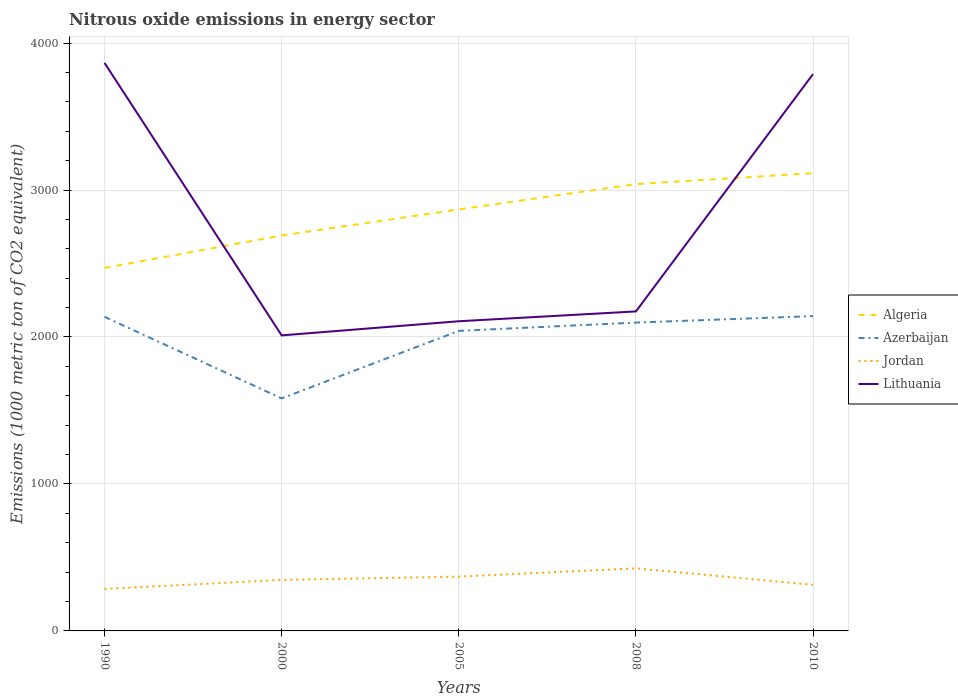Is the number of lines equal to the number of legend labels?
Offer a terse response. Yes. Across all years, what is the maximum amount of nitrous oxide emitted in Azerbaijan?
Keep it short and to the point. 1582.1. In which year was the amount of nitrous oxide emitted in Jordan maximum?
Your answer should be very brief. 1990. What is the total amount of nitrous oxide emitted in Lithuania in the graph?
Offer a terse response. -1778.3. What is the difference between the highest and the second highest amount of nitrous oxide emitted in Jordan?
Your response must be concise. 140.1. How many lines are there?
Offer a very short reply. 4. What is the difference between two consecutive major ticks on the Y-axis?
Your response must be concise. 1000. Does the graph contain any zero values?
Your answer should be compact. No. Does the graph contain grids?
Keep it short and to the point. Yes. How are the legend labels stacked?
Your answer should be compact. Vertical. What is the title of the graph?
Offer a terse response. Nitrous oxide emissions in energy sector. Does "Philippines" appear as one of the legend labels in the graph?
Offer a very short reply. No. What is the label or title of the X-axis?
Offer a terse response. Years. What is the label or title of the Y-axis?
Offer a very short reply. Emissions (1000 metric ton of CO2 equivalent). What is the Emissions (1000 metric ton of CO2 equivalent) in Algeria in 1990?
Make the answer very short. 2469.5. What is the Emissions (1000 metric ton of CO2 equivalent) of Azerbaijan in 1990?
Keep it short and to the point. 2137.1. What is the Emissions (1000 metric ton of CO2 equivalent) of Jordan in 1990?
Your response must be concise. 285.6. What is the Emissions (1000 metric ton of CO2 equivalent) of Lithuania in 1990?
Provide a short and direct response. 3865. What is the Emissions (1000 metric ton of CO2 equivalent) of Algeria in 2000?
Your response must be concise. 2690.4. What is the Emissions (1000 metric ton of CO2 equivalent) of Azerbaijan in 2000?
Offer a very short reply. 1582.1. What is the Emissions (1000 metric ton of CO2 equivalent) in Jordan in 2000?
Offer a very short reply. 347.2. What is the Emissions (1000 metric ton of CO2 equivalent) of Lithuania in 2000?
Your response must be concise. 2010.8. What is the Emissions (1000 metric ton of CO2 equivalent) of Algeria in 2005?
Your response must be concise. 2868.2. What is the Emissions (1000 metric ton of CO2 equivalent) in Azerbaijan in 2005?
Provide a succinct answer. 2041.5. What is the Emissions (1000 metric ton of CO2 equivalent) of Jordan in 2005?
Your response must be concise. 369.5. What is the Emissions (1000 metric ton of CO2 equivalent) of Lithuania in 2005?
Offer a very short reply. 2107. What is the Emissions (1000 metric ton of CO2 equivalent) in Algeria in 2008?
Ensure brevity in your answer.  3040.1. What is the Emissions (1000 metric ton of CO2 equivalent) in Azerbaijan in 2008?
Your response must be concise. 2098. What is the Emissions (1000 metric ton of CO2 equivalent) in Jordan in 2008?
Keep it short and to the point. 425.7. What is the Emissions (1000 metric ton of CO2 equivalent) in Lithuania in 2008?
Make the answer very short. 2173.9. What is the Emissions (1000 metric ton of CO2 equivalent) in Algeria in 2010?
Give a very brief answer. 3114.6. What is the Emissions (1000 metric ton of CO2 equivalent) of Azerbaijan in 2010?
Provide a short and direct response. 2142.1. What is the Emissions (1000 metric ton of CO2 equivalent) of Jordan in 2010?
Provide a succinct answer. 313.4. What is the Emissions (1000 metric ton of CO2 equivalent) in Lithuania in 2010?
Your answer should be very brief. 3789.1. Across all years, what is the maximum Emissions (1000 metric ton of CO2 equivalent) of Algeria?
Make the answer very short. 3114.6. Across all years, what is the maximum Emissions (1000 metric ton of CO2 equivalent) in Azerbaijan?
Your response must be concise. 2142.1. Across all years, what is the maximum Emissions (1000 metric ton of CO2 equivalent) in Jordan?
Give a very brief answer. 425.7. Across all years, what is the maximum Emissions (1000 metric ton of CO2 equivalent) in Lithuania?
Your response must be concise. 3865. Across all years, what is the minimum Emissions (1000 metric ton of CO2 equivalent) in Algeria?
Offer a very short reply. 2469.5. Across all years, what is the minimum Emissions (1000 metric ton of CO2 equivalent) of Azerbaijan?
Provide a succinct answer. 1582.1. Across all years, what is the minimum Emissions (1000 metric ton of CO2 equivalent) of Jordan?
Your response must be concise. 285.6. Across all years, what is the minimum Emissions (1000 metric ton of CO2 equivalent) in Lithuania?
Your answer should be compact. 2010.8. What is the total Emissions (1000 metric ton of CO2 equivalent) in Algeria in the graph?
Your answer should be compact. 1.42e+04. What is the total Emissions (1000 metric ton of CO2 equivalent) of Azerbaijan in the graph?
Ensure brevity in your answer.  1.00e+04. What is the total Emissions (1000 metric ton of CO2 equivalent) in Jordan in the graph?
Provide a succinct answer. 1741.4. What is the total Emissions (1000 metric ton of CO2 equivalent) of Lithuania in the graph?
Your answer should be very brief. 1.39e+04. What is the difference between the Emissions (1000 metric ton of CO2 equivalent) of Algeria in 1990 and that in 2000?
Your response must be concise. -220.9. What is the difference between the Emissions (1000 metric ton of CO2 equivalent) of Azerbaijan in 1990 and that in 2000?
Your answer should be compact. 555. What is the difference between the Emissions (1000 metric ton of CO2 equivalent) in Jordan in 1990 and that in 2000?
Your response must be concise. -61.6. What is the difference between the Emissions (1000 metric ton of CO2 equivalent) in Lithuania in 1990 and that in 2000?
Provide a short and direct response. 1854.2. What is the difference between the Emissions (1000 metric ton of CO2 equivalent) in Algeria in 1990 and that in 2005?
Make the answer very short. -398.7. What is the difference between the Emissions (1000 metric ton of CO2 equivalent) in Azerbaijan in 1990 and that in 2005?
Provide a short and direct response. 95.6. What is the difference between the Emissions (1000 metric ton of CO2 equivalent) of Jordan in 1990 and that in 2005?
Give a very brief answer. -83.9. What is the difference between the Emissions (1000 metric ton of CO2 equivalent) in Lithuania in 1990 and that in 2005?
Offer a very short reply. 1758. What is the difference between the Emissions (1000 metric ton of CO2 equivalent) of Algeria in 1990 and that in 2008?
Give a very brief answer. -570.6. What is the difference between the Emissions (1000 metric ton of CO2 equivalent) in Azerbaijan in 1990 and that in 2008?
Provide a succinct answer. 39.1. What is the difference between the Emissions (1000 metric ton of CO2 equivalent) of Jordan in 1990 and that in 2008?
Your answer should be compact. -140.1. What is the difference between the Emissions (1000 metric ton of CO2 equivalent) of Lithuania in 1990 and that in 2008?
Offer a terse response. 1691.1. What is the difference between the Emissions (1000 metric ton of CO2 equivalent) in Algeria in 1990 and that in 2010?
Your answer should be compact. -645.1. What is the difference between the Emissions (1000 metric ton of CO2 equivalent) of Jordan in 1990 and that in 2010?
Provide a succinct answer. -27.8. What is the difference between the Emissions (1000 metric ton of CO2 equivalent) of Lithuania in 1990 and that in 2010?
Your answer should be very brief. 75.9. What is the difference between the Emissions (1000 metric ton of CO2 equivalent) of Algeria in 2000 and that in 2005?
Offer a very short reply. -177.8. What is the difference between the Emissions (1000 metric ton of CO2 equivalent) in Azerbaijan in 2000 and that in 2005?
Provide a succinct answer. -459.4. What is the difference between the Emissions (1000 metric ton of CO2 equivalent) of Jordan in 2000 and that in 2005?
Offer a terse response. -22.3. What is the difference between the Emissions (1000 metric ton of CO2 equivalent) in Lithuania in 2000 and that in 2005?
Make the answer very short. -96.2. What is the difference between the Emissions (1000 metric ton of CO2 equivalent) of Algeria in 2000 and that in 2008?
Your answer should be very brief. -349.7. What is the difference between the Emissions (1000 metric ton of CO2 equivalent) in Azerbaijan in 2000 and that in 2008?
Give a very brief answer. -515.9. What is the difference between the Emissions (1000 metric ton of CO2 equivalent) of Jordan in 2000 and that in 2008?
Offer a terse response. -78.5. What is the difference between the Emissions (1000 metric ton of CO2 equivalent) in Lithuania in 2000 and that in 2008?
Offer a very short reply. -163.1. What is the difference between the Emissions (1000 metric ton of CO2 equivalent) of Algeria in 2000 and that in 2010?
Provide a short and direct response. -424.2. What is the difference between the Emissions (1000 metric ton of CO2 equivalent) of Azerbaijan in 2000 and that in 2010?
Provide a short and direct response. -560. What is the difference between the Emissions (1000 metric ton of CO2 equivalent) in Jordan in 2000 and that in 2010?
Offer a terse response. 33.8. What is the difference between the Emissions (1000 metric ton of CO2 equivalent) in Lithuania in 2000 and that in 2010?
Your answer should be compact. -1778.3. What is the difference between the Emissions (1000 metric ton of CO2 equivalent) of Algeria in 2005 and that in 2008?
Give a very brief answer. -171.9. What is the difference between the Emissions (1000 metric ton of CO2 equivalent) of Azerbaijan in 2005 and that in 2008?
Provide a succinct answer. -56.5. What is the difference between the Emissions (1000 metric ton of CO2 equivalent) of Jordan in 2005 and that in 2008?
Offer a very short reply. -56.2. What is the difference between the Emissions (1000 metric ton of CO2 equivalent) of Lithuania in 2005 and that in 2008?
Offer a very short reply. -66.9. What is the difference between the Emissions (1000 metric ton of CO2 equivalent) of Algeria in 2005 and that in 2010?
Your answer should be compact. -246.4. What is the difference between the Emissions (1000 metric ton of CO2 equivalent) in Azerbaijan in 2005 and that in 2010?
Provide a succinct answer. -100.6. What is the difference between the Emissions (1000 metric ton of CO2 equivalent) in Jordan in 2005 and that in 2010?
Your answer should be very brief. 56.1. What is the difference between the Emissions (1000 metric ton of CO2 equivalent) in Lithuania in 2005 and that in 2010?
Provide a succinct answer. -1682.1. What is the difference between the Emissions (1000 metric ton of CO2 equivalent) in Algeria in 2008 and that in 2010?
Give a very brief answer. -74.5. What is the difference between the Emissions (1000 metric ton of CO2 equivalent) in Azerbaijan in 2008 and that in 2010?
Give a very brief answer. -44.1. What is the difference between the Emissions (1000 metric ton of CO2 equivalent) in Jordan in 2008 and that in 2010?
Provide a succinct answer. 112.3. What is the difference between the Emissions (1000 metric ton of CO2 equivalent) in Lithuania in 2008 and that in 2010?
Your response must be concise. -1615.2. What is the difference between the Emissions (1000 metric ton of CO2 equivalent) of Algeria in 1990 and the Emissions (1000 metric ton of CO2 equivalent) of Azerbaijan in 2000?
Keep it short and to the point. 887.4. What is the difference between the Emissions (1000 metric ton of CO2 equivalent) in Algeria in 1990 and the Emissions (1000 metric ton of CO2 equivalent) in Jordan in 2000?
Ensure brevity in your answer.  2122.3. What is the difference between the Emissions (1000 metric ton of CO2 equivalent) of Algeria in 1990 and the Emissions (1000 metric ton of CO2 equivalent) of Lithuania in 2000?
Your answer should be compact. 458.7. What is the difference between the Emissions (1000 metric ton of CO2 equivalent) of Azerbaijan in 1990 and the Emissions (1000 metric ton of CO2 equivalent) of Jordan in 2000?
Offer a very short reply. 1789.9. What is the difference between the Emissions (1000 metric ton of CO2 equivalent) in Azerbaijan in 1990 and the Emissions (1000 metric ton of CO2 equivalent) in Lithuania in 2000?
Your response must be concise. 126.3. What is the difference between the Emissions (1000 metric ton of CO2 equivalent) in Jordan in 1990 and the Emissions (1000 metric ton of CO2 equivalent) in Lithuania in 2000?
Keep it short and to the point. -1725.2. What is the difference between the Emissions (1000 metric ton of CO2 equivalent) of Algeria in 1990 and the Emissions (1000 metric ton of CO2 equivalent) of Azerbaijan in 2005?
Provide a short and direct response. 428. What is the difference between the Emissions (1000 metric ton of CO2 equivalent) in Algeria in 1990 and the Emissions (1000 metric ton of CO2 equivalent) in Jordan in 2005?
Ensure brevity in your answer.  2100. What is the difference between the Emissions (1000 metric ton of CO2 equivalent) of Algeria in 1990 and the Emissions (1000 metric ton of CO2 equivalent) of Lithuania in 2005?
Give a very brief answer. 362.5. What is the difference between the Emissions (1000 metric ton of CO2 equivalent) of Azerbaijan in 1990 and the Emissions (1000 metric ton of CO2 equivalent) of Jordan in 2005?
Your answer should be compact. 1767.6. What is the difference between the Emissions (1000 metric ton of CO2 equivalent) in Azerbaijan in 1990 and the Emissions (1000 metric ton of CO2 equivalent) in Lithuania in 2005?
Provide a short and direct response. 30.1. What is the difference between the Emissions (1000 metric ton of CO2 equivalent) in Jordan in 1990 and the Emissions (1000 metric ton of CO2 equivalent) in Lithuania in 2005?
Keep it short and to the point. -1821.4. What is the difference between the Emissions (1000 metric ton of CO2 equivalent) of Algeria in 1990 and the Emissions (1000 metric ton of CO2 equivalent) of Azerbaijan in 2008?
Provide a succinct answer. 371.5. What is the difference between the Emissions (1000 metric ton of CO2 equivalent) in Algeria in 1990 and the Emissions (1000 metric ton of CO2 equivalent) in Jordan in 2008?
Ensure brevity in your answer.  2043.8. What is the difference between the Emissions (1000 metric ton of CO2 equivalent) in Algeria in 1990 and the Emissions (1000 metric ton of CO2 equivalent) in Lithuania in 2008?
Provide a succinct answer. 295.6. What is the difference between the Emissions (1000 metric ton of CO2 equivalent) of Azerbaijan in 1990 and the Emissions (1000 metric ton of CO2 equivalent) of Jordan in 2008?
Keep it short and to the point. 1711.4. What is the difference between the Emissions (1000 metric ton of CO2 equivalent) in Azerbaijan in 1990 and the Emissions (1000 metric ton of CO2 equivalent) in Lithuania in 2008?
Make the answer very short. -36.8. What is the difference between the Emissions (1000 metric ton of CO2 equivalent) of Jordan in 1990 and the Emissions (1000 metric ton of CO2 equivalent) of Lithuania in 2008?
Your response must be concise. -1888.3. What is the difference between the Emissions (1000 metric ton of CO2 equivalent) of Algeria in 1990 and the Emissions (1000 metric ton of CO2 equivalent) of Azerbaijan in 2010?
Provide a succinct answer. 327.4. What is the difference between the Emissions (1000 metric ton of CO2 equivalent) of Algeria in 1990 and the Emissions (1000 metric ton of CO2 equivalent) of Jordan in 2010?
Your answer should be very brief. 2156.1. What is the difference between the Emissions (1000 metric ton of CO2 equivalent) in Algeria in 1990 and the Emissions (1000 metric ton of CO2 equivalent) in Lithuania in 2010?
Ensure brevity in your answer.  -1319.6. What is the difference between the Emissions (1000 metric ton of CO2 equivalent) of Azerbaijan in 1990 and the Emissions (1000 metric ton of CO2 equivalent) of Jordan in 2010?
Provide a succinct answer. 1823.7. What is the difference between the Emissions (1000 metric ton of CO2 equivalent) of Azerbaijan in 1990 and the Emissions (1000 metric ton of CO2 equivalent) of Lithuania in 2010?
Make the answer very short. -1652. What is the difference between the Emissions (1000 metric ton of CO2 equivalent) in Jordan in 1990 and the Emissions (1000 metric ton of CO2 equivalent) in Lithuania in 2010?
Ensure brevity in your answer.  -3503.5. What is the difference between the Emissions (1000 metric ton of CO2 equivalent) of Algeria in 2000 and the Emissions (1000 metric ton of CO2 equivalent) of Azerbaijan in 2005?
Your answer should be very brief. 648.9. What is the difference between the Emissions (1000 metric ton of CO2 equivalent) in Algeria in 2000 and the Emissions (1000 metric ton of CO2 equivalent) in Jordan in 2005?
Make the answer very short. 2320.9. What is the difference between the Emissions (1000 metric ton of CO2 equivalent) in Algeria in 2000 and the Emissions (1000 metric ton of CO2 equivalent) in Lithuania in 2005?
Provide a short and direct response. 583.4. What is the difference between the Emissions (1000 metric ton of CO2 equivalent) of Azerbaijan in 2000 and the Emissions (1000 metric ton of CO2 equivalent) of Jordan in 2005?
Offer a very short reply. 1212.6. What is the difference between the Emissions (1000 metric ton of CO2 equivalent) in Azerbaijan in 2000 and the Emissions (1000 metric ton of CO2 equivalent) in Lithuania in 2005?
Your answer should be compact. -524.9. What is the difference between the Emissions (1000 metric ton of CO2 equivalent) in Jordan in 2000 and the Emissions (1000 metric ton of CO2 equivalent) in Lithuania in 2005?
Give a very brief answer. -1759.8. What is the difference between the Emissions (1000 metric ton of CO2 equivalent) in Algeria in 2000 and the Emissions (1000 metric ton of CO2 equivalent) in Azerbaijan in 2008?
Ensure brevity in your answer.  592.4. What is the difference between the Emissions (1000 metric ton of CO2 equivalent) of Algeria in 2000 and the Emissions (1000 metric ton of CO2 equivalent) of Jordan in 2008?
Your answer should be compact. 2264.7. What is the difference between the Emissions (1000 metric ton of CO2 equivalent) in Algeria in 2000 and the Emissions (1000 metric ton of CO2 equivalent) in Lithuania in 2008?
Your answer should be very brief. 516.5. What is the difference between the Emissions (1000 metric ton of CO2 equivalent) in Azerbaijan in 2000 and the Emissions (1000 metric ton of CO2 equivalent) in Jordan in 2008?
Your answer should be compact. 1156.4. What is the difference between the Emissions (1000 metric ton of CO2 equivalent) of Azerbaijan in 2000 and the Emissions (1000 metric ton of CO2 equivalent) of Lithuania in 2008?
Offer a very short reply. -591.8. What is the difference between the Emissions (1000 metric ton of CO2 equivalent) in Jordan in 2000 and the Emissions (1000 metric ton of CO2 equivalent) in Lithuania in 2008?
Ensure brevity in your answer.  -1826.7. What is the difference between the Emissions (1000 metric ton of CO2 equivalent) in Algeria in 2000 and the Emissions (1000 metric ton of CO2 equivalent) in Azerbaijan in 2010?
Your answer should be compact. 548.3. What is the difference between the Emissions (1000 metric ton of CO2 equivalent) of Algeria in 2000 and the Emissions (1000 metric ton of CO2 equivalent) of Jordan in 2010?
Provide a short and direct response. 2377. What is the difference between the Emissions (1000 metric ton of CO2 equivalent) in Algeria in 2000 and the Emissions (1000 metric ton of CO2 equivalent) in Lithuania in 2010?
Your answer should be very brief. -1098.7. What is the difference between the Emissions (1000 metric ton of CO2 equivalent) of Azerbaijan in 2000 and the Emissions (1000 metric ton of CO2 equivalent) of Jordan in 2010?
Your answer should be compact. 1268.7. What is the difference between the Emissions (1000 metric ton of CO2 equivalent) in Azerbaijan in 2000 and the Emissions (1000 metric ton of CO2 equivalent) in Lithuania in 2010?
Ensure brevity in your answer.  -2207. What is the difference between the Emissions (1000 metric ton of CO2 equivalent) in Jordan in 2000 and the Emissions (1000 metric ton of CO2 equivalent) in Lithuania in 2010?
Your answer should be compact. -3441.9. What is the difference between the Emissions (1000 metric ton of CO2 equivalent) of Algeria in 2005 and the Emissions (1000 metric ton of CO2 equivalent) of Azerbaijan in 2008?
Offer a terse response. 770.2. What is the difference between the Emissions (1000 metric ton of CO2 equivalent) in Algeria in 2005 and the Emissions (1000 metric ton of CO2 equivalent) in Jordan in 2008?
Provide a succinct answer. 2442.5. What is the difference between the Emissions (1000 metric ton of CO2 equivalent) of Algeria in 2005 and the Emissions (1000 metric ton of CO2 equivalent) of Lithuania in 2008?
Your answer should be very brief. 694.3. What is the difference between the Emissions (1000 metric ton of CO2 equivalent) of Azerbaijan in 2005 and the Emissions (1000 metric ton of CO2 equivalent) of Jordan in 2008?
Give a very brief answer. 1615.8. What is the difference between the Emissions (1000 metric ton of CO2 equivalent) in Azerbaijan in 2005 and the Emissions (1000 metric ton of CO2 equivalent) in Lithuania in 2008?
Offer a very short reply. -132.4. What is the difference between the Emissions (1000 metric ton of CO2 equivalent) of Jordan in 2005 and the Emissions (1000 metric ton of CO2 equivalent) of Lithuania in 2008?
Keep it short and to the point. -1804.4. What is the difference between the Emissions (1000 metric ton of CO2 equivalent) of Algeria in 2005 and the Emissions (1000 metric ton of CO2 equivalent) of Azerbaijan in 2010?
Your response must be concise. 726.1. What is the difference between the Emissions (1000 metric ton of CO2 equivalent) in Algeria in 2005 and the Emissions (1000 metric ton of CO2 equivalent) in Jordan in 2010?
Give a very brief answer. 2554.8. What is the difference between the Emissions (1000 metric ton of CO2 equivalent) in Algeria in 2005 and the Emissions (1000 metric ton of CO2 equivalent) in Lithuania in 2010?
Keep it short and to the point. -920.9. What is the difference between the Emissions (1000 metric ton of CO2 equivalent) in Azerbaijan in 2005 and the Emissions (1000 metric ton of CO2 equivalent) in Jordan in 2010?
Your answer should be very brief. 1728.1. What is the difference between the Emissions (1000 metric ton of CO2 equivalent) in Azerbaijan in 2005 and the Emissions (1000 metric ton of CO2 equivalent) in Lithuania in 2010?
Your answer should be very brief. -1747.6. What is the difference between the Emissions (1000 metric ton of CO2 equivalent) of Jordan in 2005 and the Emissions (1000 metric ton of CO2 equivalent) of Lithuania in 2010?
Provide a short and direct response. -3419.6. What is the difference between the Emissions (1000 metric ton of CO2 equivalent) in Algeria in 2008 and the Emissions (1000 metric ton of CO2 equivalent) in Azerbaijan in 2010?
Provide a short and direct response. 898. What is the difference between the Emissions (1000 metric ton of CO2 equivalent) of Algeria in 2008 and the Emissions (1000 metric ton of CO2 equivalent) of Jordan in 2010?
Keep it short and to the point. 2726.7. What is the difference between the Emissions (1000 metric ton of CO2 equivalent) in Algeria in 2008 and the Emissions (1000 metric ton of CO2 equivalent) in Lithuania in 2010?
Your answer should be compact. -749. What is the difference between the Emissions (1000 metric ton of CO2 equivalent) of Azerbaijan in 2008 and the Emissions (1000 metric ton of CO2 equivalent) of Jordan in 2010?
Make the answer very short. 1784.6. What is the difference between the Emissions (1000 metric ton of CO2 equivalent) of Azerbaijan in 2008 and the Emissions (1000 metric ton of CO2 equivalent) of Lithuania in 2010?
Your answer should be very brief. -1691.1. What is the difference between the Emissions (1000 metric ton of CO2 equivalent) of Jordan in 2008 and the Emissions (1000 metric ton of CO2 equivalent) of Lithuania in 2010?
Your answer should be compact. -3363.4. What is the average Emissions (1000 metric ton of CO2 equivalent) in Algeria per year?
Your answer should be very brief. 2836.56. What is the average Emissions (1000 metric ton of CO2 equivalent) in Azerbaijan per year?
Give a very brief answer. 2000.16. What is the average Emissions (1000 metric ton of CO2 equivalent) in Jordan per year?
Give a very brief answer. 348.28. What is the average Emissions (1000 metric ton of CO2 equivalent) in Lithuania per year?
Provide a succinct answer. 2789.16. In the year 1990, what is the difference between the Emissions (1000 metric ton of CO2 equivalent) of Algeria and Emissions (1000 metric ton of CO2 equivalent) of Azerbaijan?
Ensure brevity in your answer.  332.4. In the year 1990, what is the difference between the Emissions (1000 metric ton of CO2 equivalent) of Algeria and Emissions (1000 metric ton of CO2 equivalent) of Jordan?
Make the answer very short. 2183.9. In the year 1990, what is the difference between the Emissions (1000 metric ton of CO2 equivalent) of Algeria and Emissions (1000 metric ton of CO2 equivalent) of Lithuania?
Provide a short and direct response. -1395.5. In the year 1990, what is the difference between the Emissions (1000 metric ton of CO2 equivalent) in Azerbaijan and Emissions (1000 metric ton of CO2 equivalent) in Jordan?
Offer a terse response. 1851.5. In the year 1990, what is the difference between the Emissions (1000 metric ton of CO2 equivalent) in Azerbaijan and Emissions (1000 metric ton of CO2 equivalent) in Lithuania?
Provide a succinct answer. -1727.9. In the year 1990, what is the difference between the Emissions (1000 metric ton of CO2 equivalent) in Jordan and Emissions (1000 metric ton of CO2 equivalent) in Lithuania?
Provide a short and direct response. -3579.4. In the year 2000, what is the difference between the Emissions (1000 metric ton of CO2 equivalent) in Algeria and Emissions (1000 metric ton of CO2 equivalent) in Azerbaijan?
Give a very brief answer. 1108.3. In the year 2000, what is the difference between the Emissions (1000 metric ton of CO2 equivalent) of Algeria and Emissions (1000 metric ton of CO2 equivalent) of Jordan?
Your answer should be very brief. 2343.2. In the year 2000, what is the difference between the Emissions (1000 metric ton of CO2 equivalent) of Algeria and Emissions (1000 metric ton of CO2 equivalent) of Lithuania?
Provide a succinct answer. 679.6. In the year 2000, what is the difference between the Emissions (1000 metric ton of CO2 equivalent) of Azerbaijan and Emissions (1000 metric ton of CO2 equivalent) of Jordan?
Offer a very short reply. 1234.9. In the year 2000, what is the difference between the Emissions (1000 metric ton of CO2 equivalent) in Azerbaijan and Emissions (1000 metric ton of CO2 equivalent) in Lithuania?
Your response must be concise. -428.7. In the year 2000, what is the difference between the Emissions (1000 metric ton of CO2 equivalent) in Jordan and Emissions (1000 metric ton of CO2 equivalent) in Lithuania?
Your answer should be very brief. -1663.6. In the year 2005, what is the difference between the Emissions (1000 metric ton of CO2 equivalent) in Algeria and Emissions (1000 metric ton of CO2 equivalent) in Azerbaijan?
Offer a terse response. 826.7. In the year 2005, what is the difference between the Emissions (1000 metric ton of CO2 equivalent) in Algeria and Emissions (1000 metric ton of CO2 equivalent) in Jordan?
Provide a short and direct response. 2498.7. In the year 2005, what is the difference between the Emissions (1000 metric ton of CO2 equivalent) of Algeria and Emissions (1000 metric ton of CO2 equivalent) of Lithuania?
Give a very brief answer. 761.2. In the year 2005, what is the difference between the Emissions (1000 metric ton of CO2 equivalent) in Azerbaijan and Emissions (1000 metric ton of CO2 equivalent) in Jordan?
Give a very brief answer. 1672. In the year 2005, what is the difference between the Emissions (1000 metric ton of CO2 equivalent) in Azerbaijan and Emissions (1000 metric ton of CO2 equivalent) in Lithuania?
Provide a short and direct response. -65.5. In the year 2005, what is the difference between the Emissions (1000 metric ton of CO2 equivalent) in Jordan and Emissions (1000 metric ton of CO2 equivalent) in Lithuania?
Offer a terse response. -1737.5. In the year 2008, what is the difference between the Emissions (1000 metric ton of CO2 equivalent) of Algeria and Emissions (1000 metric ton of CO2 equivalent) of Azerbaijan?
Your answer should be very brief. 942.1. In the year 2008, what is the difference between the Emissions (1000 metric ton of CO2 equivalent) of Algeria and Emissions (1000 metric ton of CO2 equivalent) of Jordan?
Your answer should be compact. 2614.4. In the year 2008, what is the difference between the Emissions (1000 metric ton of CO2 equivalent) of Algeria and Emissions (1000 metric ton of CO2 equivalent) of Lithuania?
Your answer should be very brief. 866.2. In the year 2008, what is the difference between the Emissions (1000 metric ton of CO2 equivalent) of Azerbaijan and Emissions (1000 metric ton of CO2 equivalent) of Jordan?
Provide a short and direct response. 1672.3. In the year 2008, what is the difference between the Emissions (1000 metric ton of CO2 equivalent) of Azerbaijan and Emissions (1000 metric ton of CO2 equivalent) of Lithuania?
Your response must be concise. -75.9. In the year 2008, what is the difference between the Emissions (1000 metric ton of CO2 equivalent) of Jordan and Emissions (1000 metric ton of CO2 equivalent) of Lithuania?
Your response must be concise. -1748.2. In the year 2010, what is the difference between the Emissions (1000 metric ton of CO2 equivalent) in Algeria and Emissions (1000 metric ton of CO2 equivalent) in Azerbaijan?
Your response must be concise. 972.5. In the year 2010, what is the difference between the Emissions (1000 metric ton of CO2 equivalent) of Algeria and Emissions (1000 metric ton of CO2 equivalent) of Jordan?
Offer a very short reply. 2801.2. In the year 2010, what is the difference between the Emissions (1000 metric ton of CO2 equivalent) of Algeria and Emissions (1000 metric ton of CO2 equivalent) of Lithuania?
Give a very brief answer. -674.5. In the year 2010, what is the difference between the Emissions (1000 metric ton of CO2 equivalent) in Azerbaijan and Emissions (1000 metric ton of CO2 equivalent) in Jordan?
Provide a succinct answer. 1828.7. In the year 2010, what is the difference between the Emissions (1000 metric ton of CO2 equivalent) in Azerbaijan and Emissions (1000 metric ton of CO2 equivalent) in Lithuania?
Ensure brevity in your answer.  -1647. In the year 2010, what is the difference between the Emissions (1000 metric ton of CO2 equivalent) of Jordan and Emissions (1000 metric ton of CO2 equivalent) of Lithuania?
Keep it short and to the point. -3475.7. What is the ratio of the Emissions (1000 metric ton of CO2 equivalent) of Algeria in 1990 to that in 2000?
Give a very brief answer. 0.92. What is the ratio of the Emissions (1000 metric ton of CO2 equivalent) of Azerbaijan in 1990 to that in 2000?
Your answer should be compact. 1.35. What is the ratio of the Emissions (1000 metric ton of CO2 equivalent) of Jordan in 1990 to that in 2000?
Your answer should be compact. 0.82. What is the ratio of the Emissions (1000 metric ton of CO2 equivalent) of Lithuania in 1990 to that in 2000?
Your answer should be very brief. 1.92. What is the ratio of the Emissions (1000 metric ton of CO2 equivalent) of Algeria in 1990 to that in 2005?
Your response must be concise. 0.86. What is the ratio of the Emissions (1000 metric ton of CO2 equivalent) of Azerbaijan in 1990 to that in 2005?
Give a very brief answer. 1.05. What is the ratio of the Emissions (1000 metric ton of CO2 equivalent) in Jordan in 1990 to that in 2005?
Make the answer very short. 0.77. What is the ratio of the Emissions (1000 metric ton of CO2 equivalent) in Lithuania in 1990 to that in 2005?
Your answer should be compact. 1.83. What is the ratio of the Emissions (1000 metric ton of CO2 equivalent) of Algeria in 1990 to that in 2008?
Offer a very short reply. 0.81. What is the ratio of the Emissions (1000 metric ton of CO2 equivalent) in Azerbaijan in 1990 to that in 2008?
Your answer should be compact. 1.02. What is the ratio of the Emissions (1000 metric ton of CO2 equivalent) of Jordan in 1990 to that in 2008?
Provide a succinct answer. 0.67. What is the ratio of the Emissions (1000 metric ton of CO2 equivalent) of Lithuania in 1990 to that in 2008?
Your answer should be compact. 1.78. What is the ratio of the Emissions (1000 metric ton of CO2 equivalent) in Algeria in 1990 to that in 2010?
Provide a short and direct response. 0.79. What is the ratio of the Emissions (1000 metric ton of CO2 equivalent) of Jordan in 1990 to that in 2010?
Keep it short and to the point. 0.91. What is the ratio of the Emissions (1000 metric ton of CO2 equivalent) of Algeria in 2000 to that in 2005?
Make the answer very short. 0.94. What is the ratio of the Emissions (1000 metric ton of CO2 equivalent) of Azerbaijan in 2000 to that in 2005?
Your response must be concise. 0.78. What is the ratio of the Emissions (1000 metric ton of CO2 equivalent) in Jordan in 2000 to that in 2005?
Offer a very short reply. 0.94. What is the ratio of the Emissions (1000 metric ton of CO2 equivalent) in Lithuania in 2000 to that in 2005?
Your answer should be compact. 0.95. What is the ratio of the Emissions (1000 metric ton of CO2 equivalent) in Algeria in 2000 to that in 2008?
Your response must be concise. 0.89. What is the ratio of the Emissions (1000 metric ton of CO2 equivalent) in Azerbaijan in 2000 to that in 2008?
Your answer should be compact. 0.75. What is the ratio of the Emissions (1000 metric ton of CO2 equivalent) in Jordan in 2000 to that in 2008?
Keep it short and to the point. 0.82. What is the ratio of the Emissions (1000 metric ton of CO2 equivalent) in Lithuania in 2000 to that in 2008?
Give a very brief answer. 0.93. What is the ratio of the Emissions (1000 metric ton of CO2 equivalent) of Algeria in 2000 to that in 2010?
Provide a short and direct response. 0.86. What is the ratio of the Emissions (1000 metric ton of CO2 equivalent) of Azerbaijan in 2000 to that in 2010?
Your answer should be compact. 0.74. What is the ratio of the Emissions (1000 metric ton of CO2 equivalent) of Jordan in 2000 to that in 2010?
Keep it short and to the point. 1.11. What is the ratio of the Emissions (1000 metric ton of CO2 equivalent) of Lithuania in 2000 to that in 2010?
Ensure brevity in your answer.  0.53. What is the ratio of the Emissions (1000 metric ton of CO2 equivalent) in Algeria in 2005 to that in 2008?
Offer a very short reply. 0.94. What is the ratio of the Emissions (1000 metric ton of CO2 equivalent) of Azerbaijan in 2005 to that in 2008?
Offer a terse response. 0.97. What is the ratio of the Emissions (1000 metric ton of CO2 equivalent) of Jordan in 2005 to that in 2008?
Your answer should be compact. 0.87. What is the ratio of the Emissions (1000 metric ton of CO2 equivalent) in Lithuania in 2005 to that in 2008?
Keep it short and to the point. 0.97. What is the ratio of the Emissions (1000 metric ton of CO2 equivalent) of Algeria in 2005 to that in 2010?
Your answer should be very brief. 0.92. What is the ratio of the Emissions (1000 metric ton of CO2 equivalent) of Azerbaijan in 2005 to that in 2010?
Make the answer very short. 0.95. What is the ratio of the Emissions (1000 metric ton of CO2 equivalent) of Jordan in 2005 to that in 2010?
Make the answer very short. 1.18. What is the ratio of the Emissions (1000 metric ton of CO2 equivalent) in Lithuania in 2005 to that in 2010?
Provide a short and direct response. 0.56. What is the ratio of the Emissions (1000 metric ton of CO2 equivalent) of Algeria in 2008 to that in 2010?
Provide a short and direct response. 0.98. What is the ratio of the Emissions (1000 metric ton of CO2 equivalent) of Azerbaijan in 2008 to that in 2010?
Give a very brief answer. 0.98. What is the ratio of the Emissions (1000 metric ton of CO2 equivalent) of Jordan in 2008 to that in 2010?
Provide a short and direct response. 1.36. What is the ratio of the Emissions (1000 metric ton of CO2 equivalent) of Lithuania in 2008 to that in 2010?
Your answer should be compact. 0.57. What is the difference between the highest and the second highest Emissions (1000 metric ton of CO2 equivalent) of Algeria?
Your answer should be very brief. 74.5. What is the difference between the highest and the second highest Emissions (1000 metric ton of CO2 equivalent) in Azerbaijan?
Ensure brevity in your answer.  5. What is the difference between the highest and the second highest Emissions (1000 metric ton of CO2 equivalent) of Jordan?
Ensure brevity in your answer.  56.2. What is the difference between the highest and the second highest Emissions (1000 metric ton of CO2 equivalent) of Lithuania?
Ensure brevity in your answer.  75.9. What is the difference between the highest and the lowest Emissions (1000 metric ton of CO2 equivalent) in Algeria?
Offer a very short reply. 645.1. What is the difference between the highest and the lowest Emissions (1000 metric ton of CO2 equivalent) in Azerbaijan?
Give a very brief answer. 560. What is the difference between the highest and the lowest Emissions (1000 metric ton of CO2 equivalent) of Jordan?
Your answer should be compact. 140.1. What is the difference between the highest and the lowest Emissions (1000 metric ton of CO2 equivalent) of Lithuania?
Offer a terse response. 1854.2. 